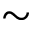Convert formula to latex. <formula><loc_0><loc_0><loc_500><loc_500>\sim</formula> 